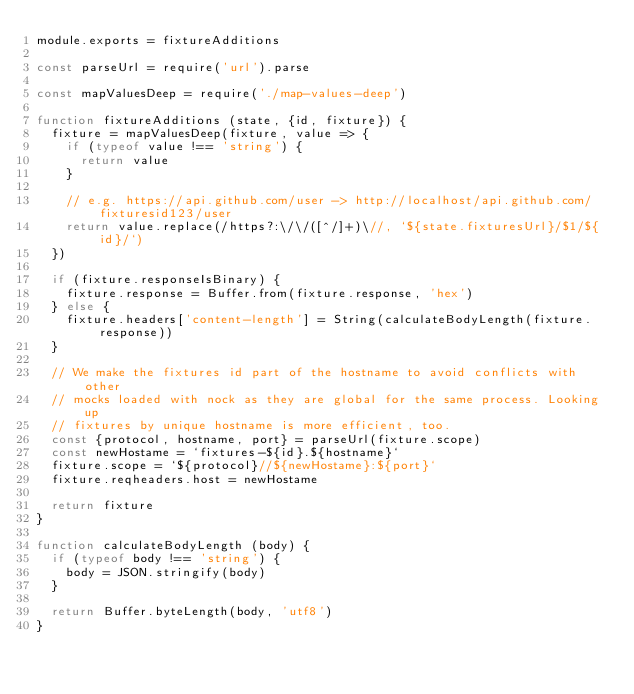Convert code to text. <code><loc_0><loc_0><loc_500><loc_500><_JavaScript_>module.exports = fixtureAdditions

const parseUrl = require('url').parse

const mapValuesDeep = require('./map-values-deep')

function fixtureAdditions (state, {id, fixture}) {
  fixture = mapValuesDeep(fixture, value => {
    if (typeof value !== 'string') {
      return value
    }

    // e.g. https://api.github.com/user -> http://localhost/api.github.com/fixturesid123/user
    return value.replace(/https?:\/\/([^/]+)\//, `${state.fixturesUrl}/$1/${id}/`)
  })

  if (fixture.responseIsBinary) {
    fixture.response = Buffer.from(fixture.response, 'hex')
  } else {
    fixture.headers['content-length'] = String(calculateBodyLength(fixture.response))
  }

  // We make the fixtures id part of the hostname to avoid conflicts with other
  // mocks loaded with nock as they are global for the same process. Looking up
  // fixtures by unique hostname is more efficient, too.
  const {protocol, hostname, port} = parseUrl(fixture.scope)
  const newHostame = `fixtures-${id}.${hostname}`
  fixture.scope = `${protocol}//${newHostame}:${port}`
  fixture.reqheaders.host = newHostame

  return fixture
}

function calculateBodyLength (body) {
  if (typeof body !== 'string') {
    body = JSON.stringify(body)
  }

  return Buffer.byteLength(body, 'utf8')
}
</code> 